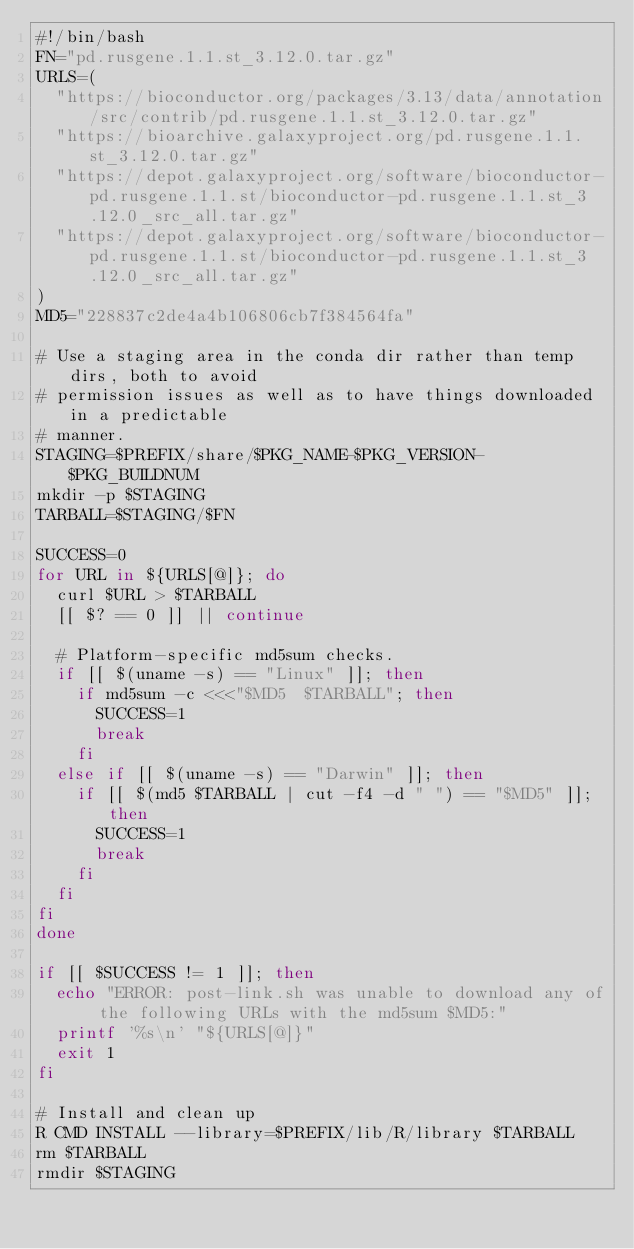<code> <loc_0><loc_0><loc_500><loc_500><_Bash_>#!/bin/bash
FN="pd.rusgene.1.1.st_3.12.0.tar.gz"
URLS=(
  "https://bioconductor.org/packages/3.13/data/annotation/src/contrib/pd.rusgene.1.1.st_3.12.0.tar.gz"
  "https://bioarchive.galaxyproject.org/pd.rusgene.1.1.st_3.12.0.tar.gz"
  "https://depot.galaxyproject.org/software/bioconductor-pd.rusgene.1.1.st/bioconductor-pd.rusgene.1.1.st_3.12.0_src_all.tar.gz"
  "https://depot.galaxyproject.org/software/bioconductor-pd.rusgene.1.1.st/bioconductor-pd.rusgene.1.1.st_3.12.0_src_all.tar.gz"
)
MD5="228837c2de4a4b106806cb7f384564fa"

# Use a staging area in the conda dir rather than temp dirs, both to avoid
# permission issues as well as to have things downloaded in a predictable
# manner.
STAGING=$PREFIX/share/$PKG_NAME-$PKG_VERSION-$PKG_BUILDNUM
mkdir -p $STAGING
TARBALL=$STAGING/$FN

SUCCESS=0
for URL in ${URLS[@]}; do
  curl $URL > $TARBALL
  [[ $? == 0 ]] || continue

  # Platform-specific md5sum checks.
  if [[ $(uname -s) == "Linux" ]]; then
    if md5sum -c <<<"$MD5  $TARBALL"; then
      SUCCESS=1
      break
    fi
  else if [[ $(uname -s) == "Darwin" ]]; then
    if [[ $(md5 $TARBALL | cut -f4 -d " ") == "$MD5" ]]; then
      SUCCESS=1
      break
    fi
  fi
fi
done

if [[ $SUCCESS != 1 ]]; then
  echo "ERROR: post-link.sh was unable to download any of the following URLs with the md5sum $MD5:"
  printf '%s\n' "${URLS[@]}"
  exit 1
fi

# Install and clean up
R CMD INSTALL --library=$PREFIX/lib/R/library $TARBALL
rm $TARBALL
rmdir $STAGING
</code> 